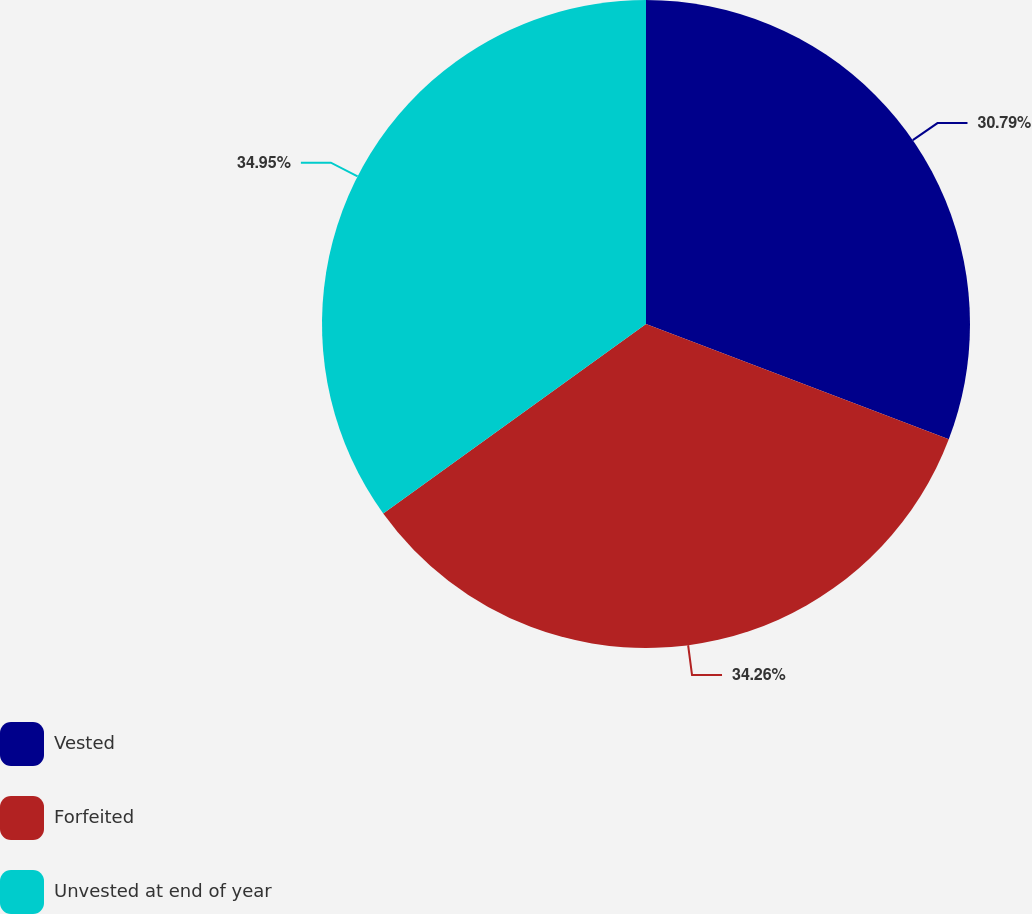Convert chart. <chart><loc_0><loc_0><loc_500><loc_500><pie_chart><fcel>Vested<fcel>Forfeited<fcel>Unvested at end of year<nl><fcel>30.79%<fcel>34.26%<fcel>34.94%<nl></chart> 